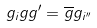<formula> <loc_0><loc_0><loc_500><loc_500>g _ { i } g g ^ { \prime } = \overline { g } g _ { i ^ { \prime \prime } }</formula> 